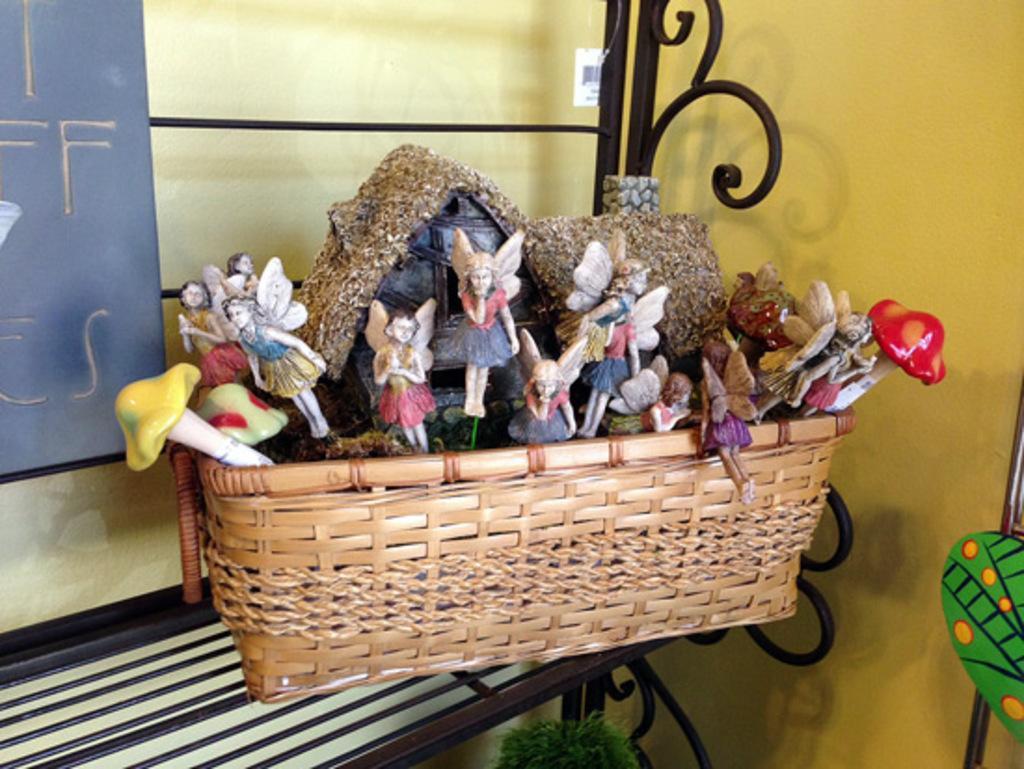Can you describe this image briefly? In this image there is a basket on the metal bench. In the basket there are toys and a small house. In the background there is a wall. On the right side bottom there is an art. There is a board attached to the bench. At the bottom there is grass. 